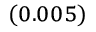Convert formula to latex. <formula><loc_0><loc_0><loc_500><loc_500>_ { ( 0 . 0 0 5 ) }</formula> 